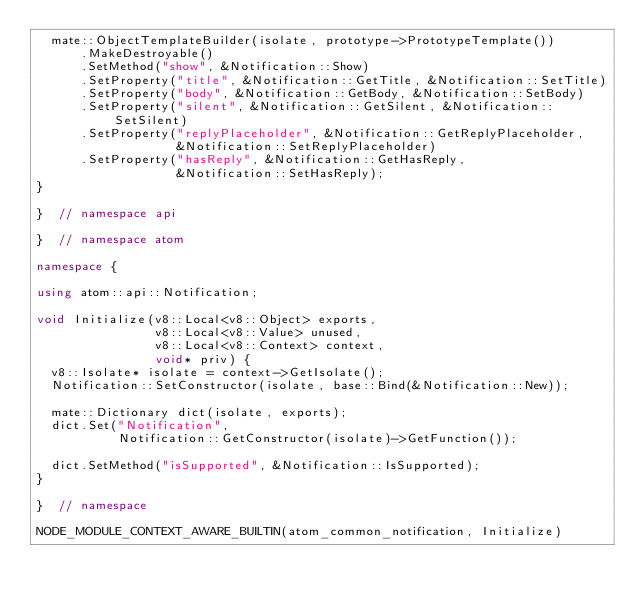<code> <loc_0><loc_0><loc_500><loc_500><_C++_>  mate::ObjectTemplateBuilder(isolate, prototype->PrototypeTemplate())
      .MakeDestroyable()
      .SetMethod("show", &Notification::Show)
      .SetProperty("title", &Notification::GetTitle, &Notification::SetTitle)
      .SetProperty("body", &Notification::GetBody, &Notification::SetBody)
      .SetProperty("silent", &Notification::GetSilent, &Notification::SetSilent)
      .SetProperty("replyPlaceholder", &Notification::GetReplyPlaceholder,
                   &Notification::SetReplyPlaceholder)
      .SetProperty("hasReply", &Notification::GetHasReply,
                   &Notification::SetHasReply);
}

}  // namespace api

}  // namespace atom

namespace {

using atom::api::Notification;

void Initialize(v8::Local<v8::Object> exports,
                v8::Local<v8::Value> unused,
                v8::Local<v8::Context> context,
                void* priv) {
  v8::Isolate* isolate = context->GetIsolate();
  Notification::SetConstructor(isolate, base::Bind(&Notification::New));

  mate::Dictionary dict(isolate, exports);
  dict.Set("Notification",
           Notification::GetConstructor(isolate)->GetFunction());

  dict.SetMethod("isSupported", &Notification::IsSupported);
}

}  // namespace

NODE_MODULE_CONTEXT_AWARE_BUILTIN(atom_common_notification, Initialize)
</code> 